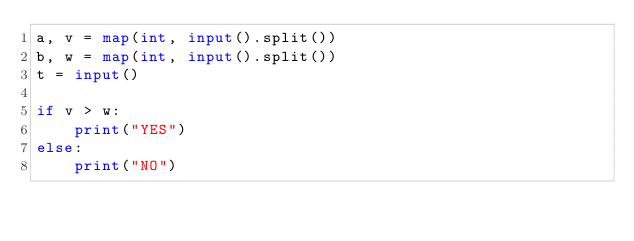Convert code to text. <code><loc_0><loc_0><loc_500><loc_500><_Python_>a, v = map(int, input().split())
b, w = map(int, input().split())
t = input()

if v > w:
    print("YES")
else:
    print("NO")</code> 